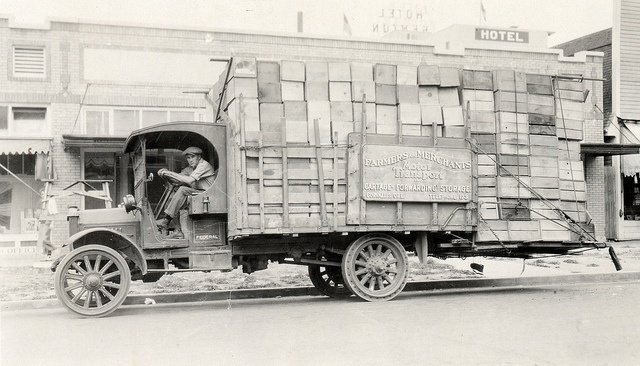Describe the objects in this image and their specific colors. I can see truck in white, lightgray, darkgray, black, and gray tones and people in white, darkgray, gray, black, and lightgray tones in this image. 